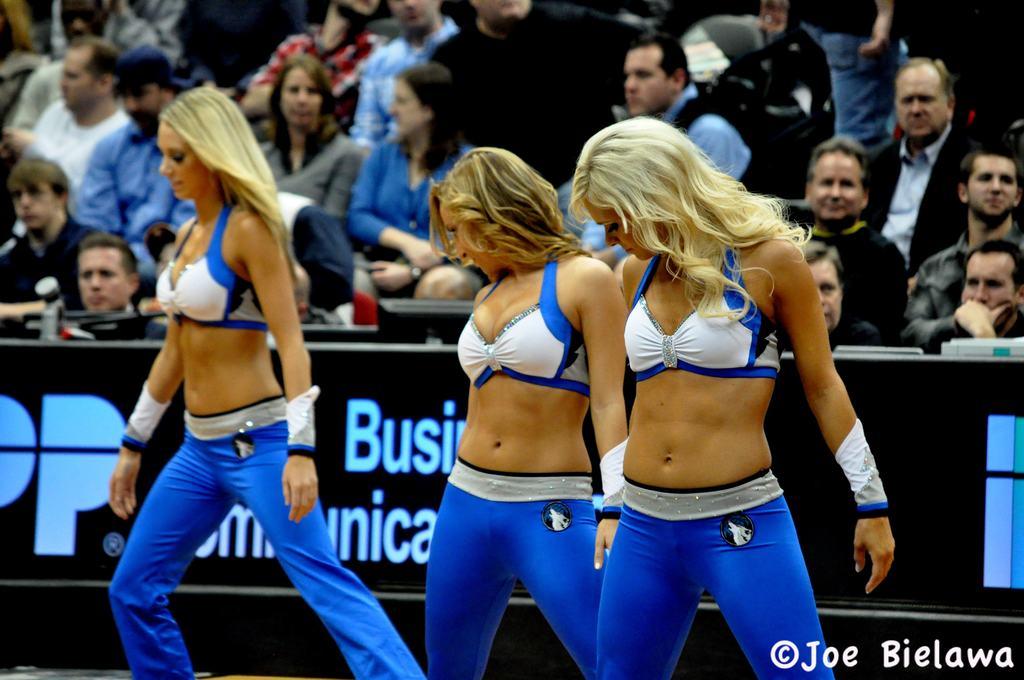Who is credited with this photo?
Keep it short and to the point. Joe bielawa. 